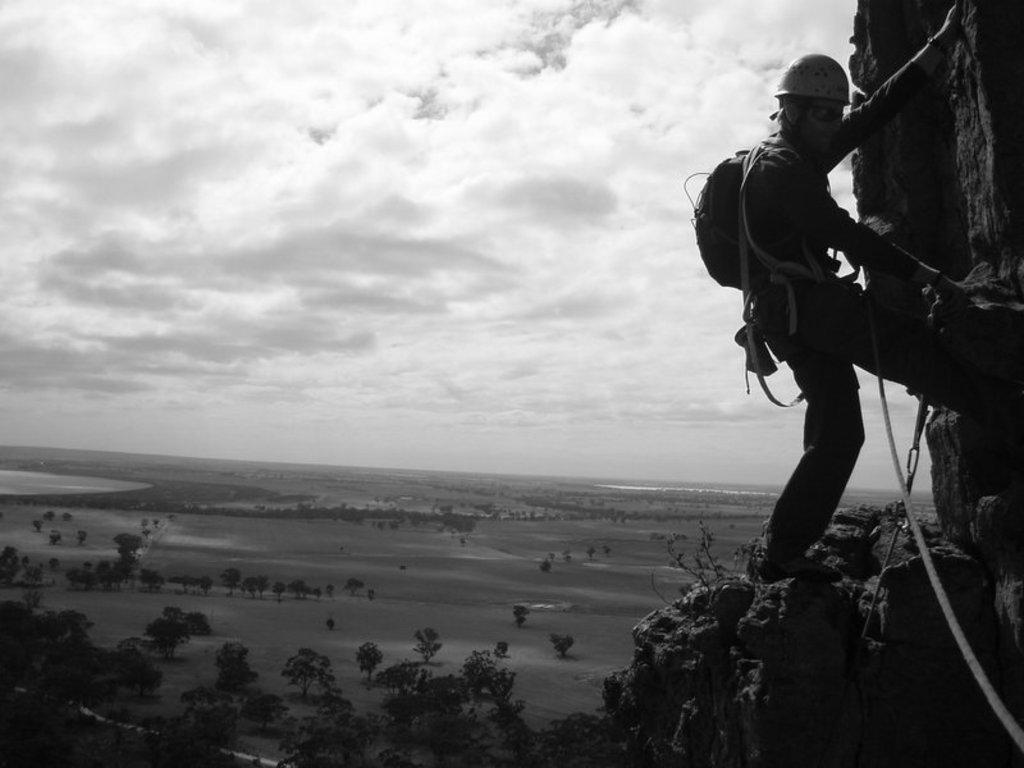What is the person in the foreground of the image doing? The person is climbing a mountain in the foreground of the image. What is the person carrying while climbing the mountain? The person has a bag. How is the person assisted in climbing the mountain? The person is using ropes. What can be seen in the background of the image? There are trees, water, and the sky visible in the background of the image. What type of location is suggested by the presence of a mountain and the other elements in the image? The image is likely taken near a mountain. What type of growth can be seen on the person's face in the image? There is no growth visible on the person's face in the image. What type of trip is the person on in the image? The image does not provide information about the person's trip. Is the person in the image a writer? The image does not provide information about the person's occupation, such as being a writer. 